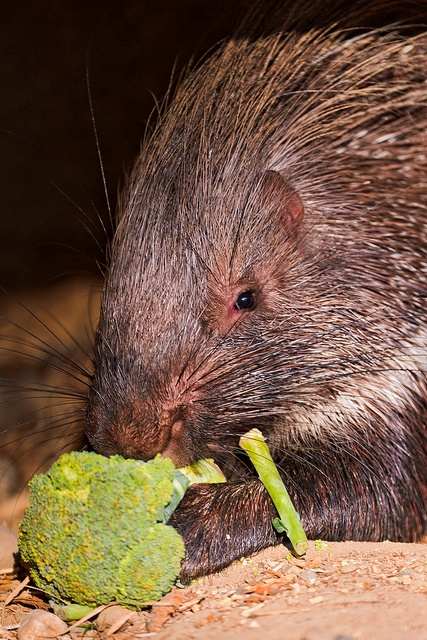Describe the objects in this image and their specific colors. I can see a broccoli in black, olive, and khaki tones in this image. 